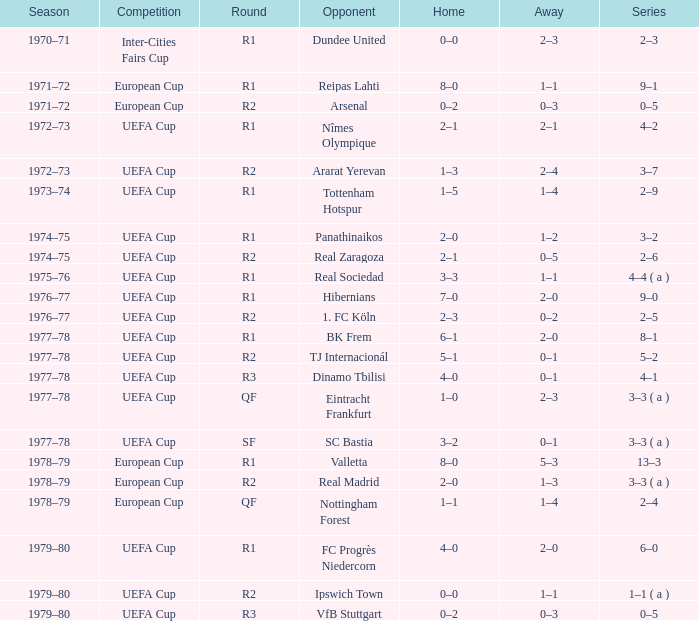Which Home has a Competition of european cup, and a Round of qf? 1–1. 